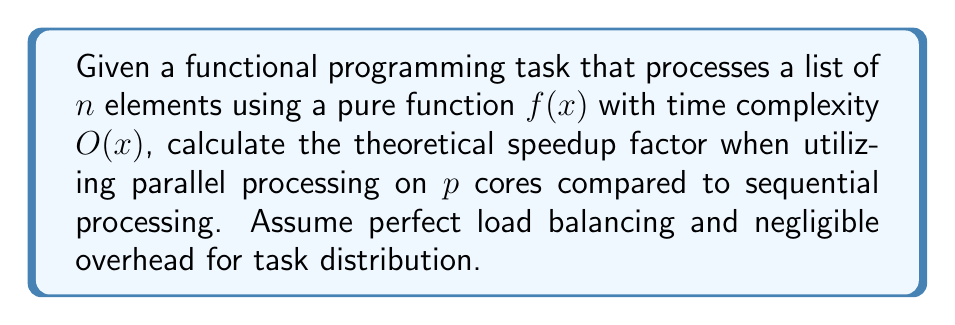Help me with this question. To solve this problem, we need to consider the following steps:

1. Calculate the total work (W) for processing n elements:
   $$W = \sum_{i=1}^n O(i) = O(n^2)$$

2. Calculate the time for sequential processing (T_s):
   $$T_s = O(n^2)$$

3. Calculate the time for parallel processing (T_p):
   In an ideal scenario with perfect load balancing, each core processes $\frac{n}{p}$ elements.
   $$T_p = O(\frac{n^2}{p})$$

4. Calculate the speedup factor (S):
   The speedup factor is defined as the ratio of sequential time to parallel time.
   $$S = \frac{T_s}{T_p} = \frac{O(n^2)}{O(\frac{n^2}{p})} = O(p)$$

In functional programming, pure functions like $f(x)$ are ideal for parallel processing as they have no side effects and don't depend on shared mutable state. This allows for easy distribution of work across multiple cores without the need for complex synchronization mechanisms.

The theoretical speedup factor of $O(p)$ suggests that the performance improvement scales linearly with the number of cores, which is the ideal scenario in parallel processing. However, it's important to note that this is a theoretical upper bound, and in practice, factors such as communication overhead and imperfect load balancing may reduce the actual speedup.
Answer: The theoretical speedup factor is $O(p)$, where $p$ is the number of cores used for parallel processing. 